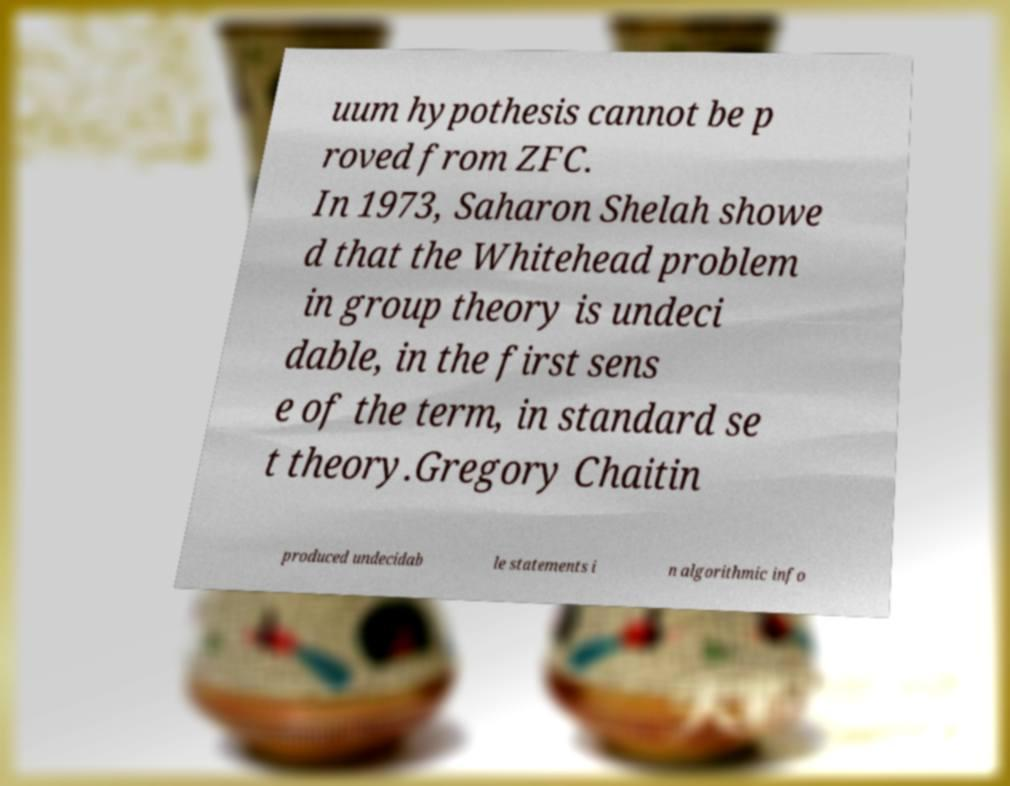For documentation purposes, I need the text within this image transcribed. Could you provide that? uum hypothesis cannot be p roved from ZFC. In 1973, Saharon Shelah showe d that the Whitehead problem in group theory is undeci dable, in the first sens e of the term, in standard se t theory.Gregory Chaitin produced undecidab le statements i n algorithmic info 